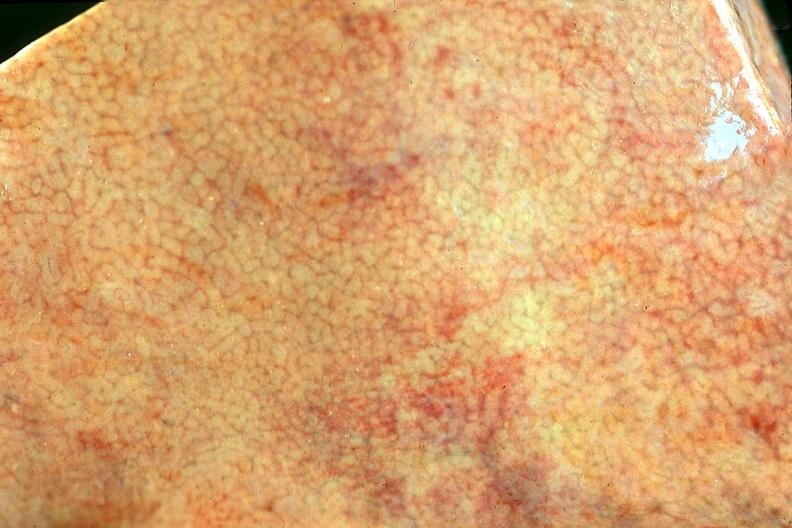what does this image show?
Answer the question using a single word or phrase. Normal liver 